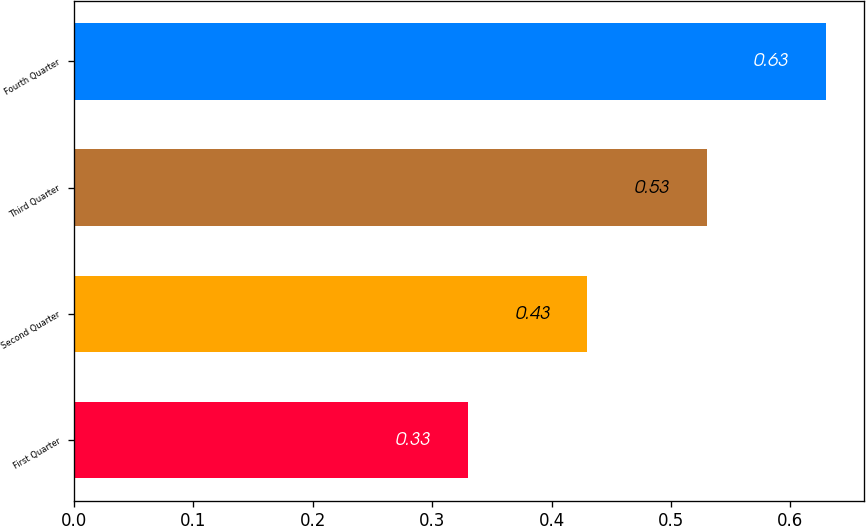Convert chart. <chart><loc_0><loc_0><loc_500><loc_500><bar_chart><fcel>First Quarter<fcel>Second Quarter<fcel>Third Quarter<fcel>Fourth Quarter<nl><fcel>0.33<fcel>0.43<fcel>0.53<fcel>0.63<nl></chart> 